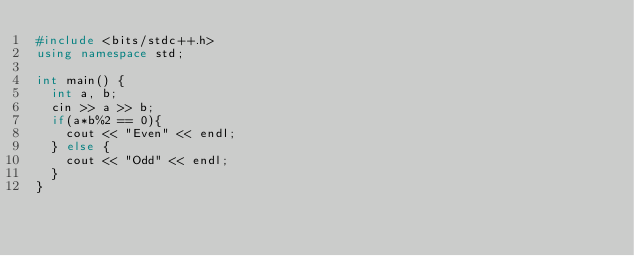Convert code to text. <code><loc_0><loc_0><loc_500><loc_500><_C++_>#include <bits/stdc++.h>
using namespace std;

int main() {
  int a, b;
  cin >> a >> b;
  if(a*b%2 == 0){
    cout << "Even" << endl;
  } else {
    cout << "Odd" << endl;
  }
}</code> 